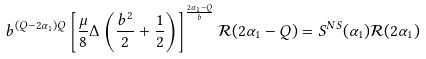Convert formula to latex. <formula><loc_0><loc_0><loc_500><loc_500>b ^ { ( Q - 2 \alpha _ { 1 } ) Q } \left [ \frac { \mu } { 8 } \Delta \left ( \frac { b ^ { 2 } } { 2 } + \frac { 1 } { 2 } \right ) \right ] ^ { \frac { 2 \alpha _ { 1 } - Q } { b } } \mathcal { R } ( 2 \alpha _ { 1 } - Q ) = S ^ { N S } ( \alpha _ { 1 } ) \mathcal { R } ( 2 \alpha _ { 1 } )</formula> 